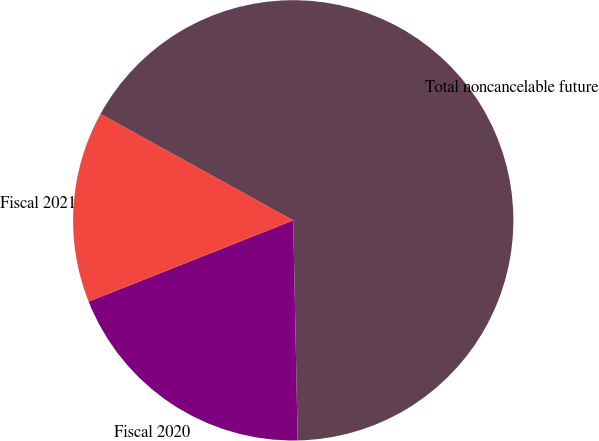Convert chart to OTSL. <chart><loc_0><loc_0><loc_500><loc_500><pie_chart><fcel>Fiscal 2020<fcel>Fiscal 2021<fcel>Total noncancelable future<nl><fcel>19.31%<fcel>14.05%<fcel>66.65%<nl></chart> 